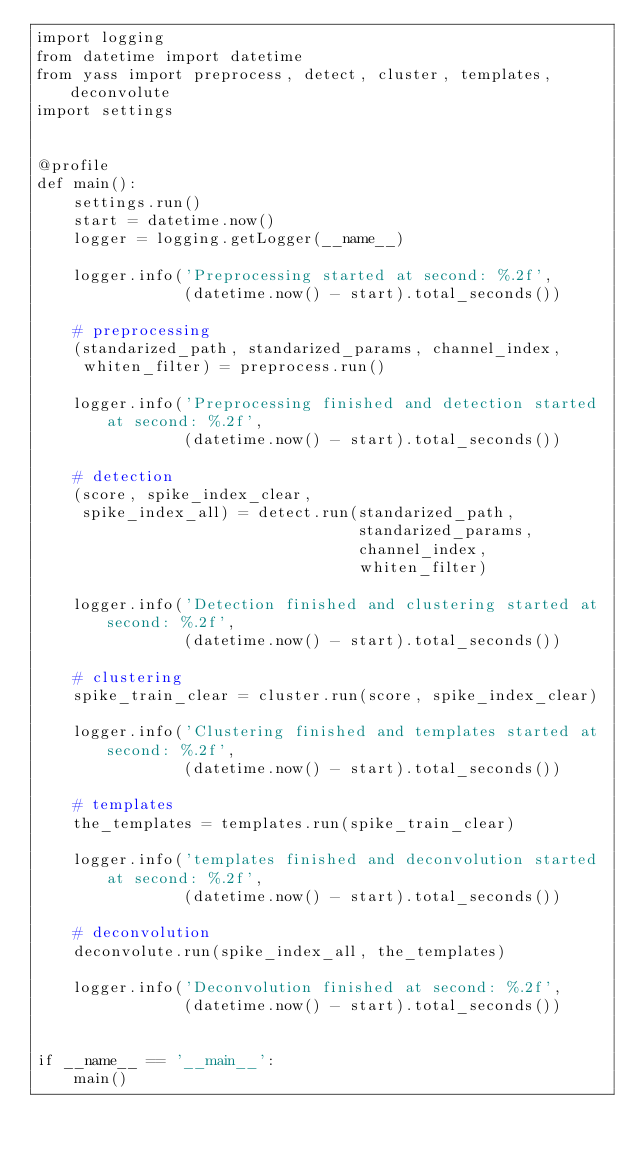Convert code to text. <code><loc_0><loc_0><loc_500><loc_500><_Python_>import logging
from datetime import datetime
from yass import preprocess, detect, cluster, templates, deconvolute
import settings


@profile
def main():
    settings.run()
    start = datetime.now()
    logger = logging.getLogger(__name__)

    logger.info('Preprocessing started at second: %.2f',
                (datetime.now() - start).total_seconds())

    # preprocessing
    (standarized_path, standarized_params, channel_index,
     whiten_filter) = preprocess.run()

    logger.info('Preprocessing finished and detection started at second: %.2f',
                (datetime.now() - start).total_seconds())

    # detection
    (score, spike_index_clear,
     spike_index_all) = detect.run(standarized_path,
                                   standarized_params,
                                   channel_index,
                                   whiten_filter)

    logger.info('Detection finished and clustering started at second: %.2f',
                (datetime.now() - start).total_seconds())

    # clustering
    spike_train_clear = cluster.run(score, spike_index_clear)

    logger.info('Clustering finished and templates started at second: %.2f',
                (datetime.now() - start).total_seconds())

    # templates
    the_templates = templates.run(spike_train_clear)

    logger.info('templates finished and deconvolution started at second: %.2f',
                (datetime.now() - start).total_seconds())

    # deconvolution
    deconvolute.run(spike_index_all, the_templates)

    logger.info('Deconvolution finished at second: %.2f',
                (datetime.now() - start).total_seconds())


if __name__ == '__main__':
    main()
</code> 